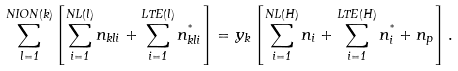Convert formula to latex. <formula><loc_0><loc_0><loc_500><loc_500>\sum _ { l = 1 } ^ { N I O N ( k ) } \left [ \sum _ { i = 1 } ^ { N L ( l ) } n _ { k l i } + \sum _ { i = 1 } ^ { L T E ( l ) } n _ { k l i } ^ { ^ { * } } \right ] = y _ { k } \left [ \sum _ { i = 1 } ^ { N L ( H ) } n _ { i } + \sum _ { i = 1 } ^ { L T E ( H ) } n _ { i } ^ { ^ { * } } + n _ { p } \right ] .</formula> 